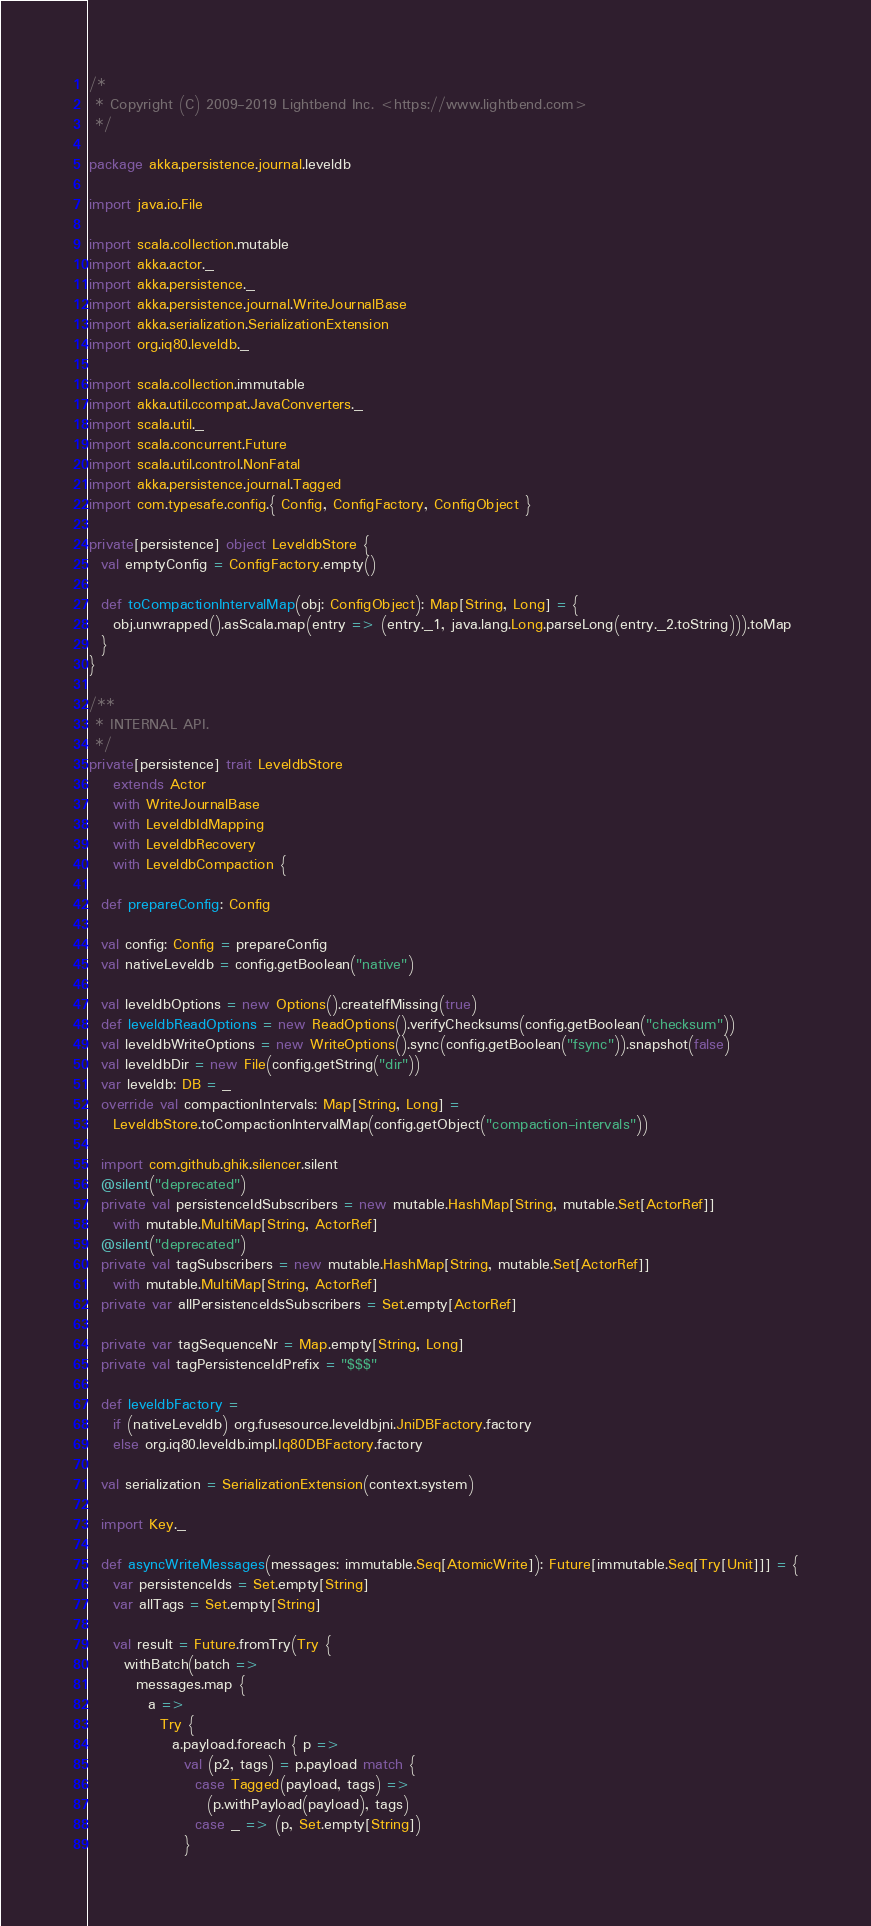Convert code to text. <code><loc_0><loc_0><loc_500><loc_500><_Scala_>/*
 * Copyright (C) 2009-2019 Lightbend Inc. <https://www.lightbend.com>
 */

package akka.persistence.journal.leveldb

import java.io.File

import scala.collection.mutable
import akka.actor._
import akka.persistence._
import akka.persistence.journal.WriteJournalBase
import akka.serialization.SerializationExtension
import org.iq80.leveldb._

import scala.collection.immutable
import akka.util.ccompat.JavaConverters._
import scala.util._
import scala.concurrent.Future
import scala.util.control.NonFatal
import akka.persistence.journal.Tagged
import com.typesafe.config.{ Config, ConfigFactory, ConfigObject }

private[persistence] object LeveldbStore {
  val emptyConfig = ConfigFactory.empty()

  def toCompactionIntervalMap(obj: ConfigObject): Map[String, Long] = {
    obj.unwrapped().asScala.map(entry => (entry._1, java.lang.Long.parseLong(entry._2.toString))).toMap
  }
}

/**
 * INTERNAL API.
 */
private[persistence] trait LeveldbStore
    extends Actor
    with WriteJournalBase
    with LeveldbIdMapping
    with LeveldbRecovery
    with LeveldbCompaction {

  def prepareConfig: Config

  val config: Config = prepareConfig
  val nativeLeveldb = config.getBoolean("native")

  val leveldbOptions = new Options().createIfMissing(true)
  def leveldbReadOptions = new ReadOptions().verifyChecksums(config.getBoolean("checksum"))
  val leveldbWriteOptions = new WriteOptions().sync(config.getBoolean("fsync")).snapshot(false)
  val leveldbDir = new File(config.getString("dir"))
  var leveldb: DB = _
  override val compactionIntervals: Map[String, Long] =
    LeveldbStore.toCompactionIntervalMap(config.getObject("compaction-intervals"))

  import com.github.ghik.silencer.silent
  @silent("deprecated")
  private val persistenceIdSubscribers = new mutable.HashMap[String, mutable.Set[ActorRef]]
    with mutable.MultiMap[String, ActorRef]
  @silent("deprecated")
  private val tagSubscribers = new mutable.HashMap[String, mutable.Set[ActorRef]]
    with mutable.MultiMap[String, ActorRef]
  private var allPersistenceIdsSubscribers = Set.empty[ActorRef]

  private var tagSequenceNr = Map.empty[String, Long]
  private val tagPersistenceIdPrefix = "$$$"

  def leveldbFactory =
    if (nativeLeveldb) org.fusesource.leveldbjni.JniDBFactory.factory
    else org.iq80.leveldb.impl.Iq80DBFactory.factory

  val serialization = SerializationExtension(context.system)

  import Key._

  def asyncWriteMessages(messages: immutable.Seq[AtomicWrite]): Future[immutable.Seq[Try[Unit]]] = {
    var persistenceIds = Set.empty[String]
    var allTags = Set.empty[String]

    val result = Future.fromTry(Try {
      withBatch(batch =>
        messages.map {
          a =>
            Try {
              a.payload.foreach { p =>
                val (p2, tags) = p.payload match {
                  case Tagged(payload, tags) =>
                    (p.withPayload(payload), tags)
                  case _ => (p, Set.empty[String])
                }</code> 